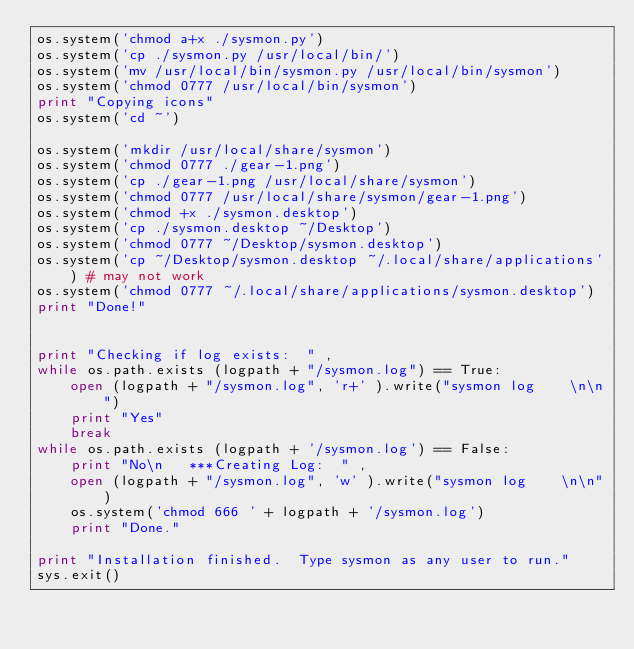Convert code to text. <code><loc_0><loc_0><loc_500><loc_500><_Python_>os.system('chmod a+x ./sysmon.py')
os.system('cp ./sysmon.py /usr/local/bin/')
os.system('mv /usr/local/bin/sysmon.py /usr/local/bin/sysmon')
os.system('chmod 0777 /usr/local/bin/sysmon')
print "Copying icons"
os.system('cd ~')

os.system('mkdir /usr/local/share/sysmon')
os.system('chmod 0777 ./gear-1.png')
os.system('cp ./gear-1.png /usr/local/share/sysmon')
os.system('chmod 0777 /usr/local/share/sysmon/gear-1.png')
os.system('chmod +x ./sysmon.desktop')
os.system('cp ./sysmon.desktop ~/Desktop')
os.system('chmod 0777 ~/Desktop/sysmon.desktop')
os.system('cp ~/Desktop/sysmon.desktop ~/.local/share/applications') # may not work
os.system('chmod 0777 ~/.local/share/applications/sysmon.desktop')
print "Done!"
	

print "Checking if log exists:  " ,
while os.path.exists (logpath + "/sysmon.log") == True: 
	open (logpath + "/sysmon.log", 'r+' ).write("sysmon log    \n\n")
	print "Yes"
	break
while os.path.exists (logpath + '/sysmon.log') == False: 
	print "No\n   ***Creating Log:  " ,
	open (logpath + "/sysmon.log", 'w' ).write("sysmon log    \n\n")
	os.system('chmod 666 ' + logpath + '/sysmon.log')
	print "Done."

print "Installation finished.  Type sysmon as any user to run."
sys.exit()
</code> 